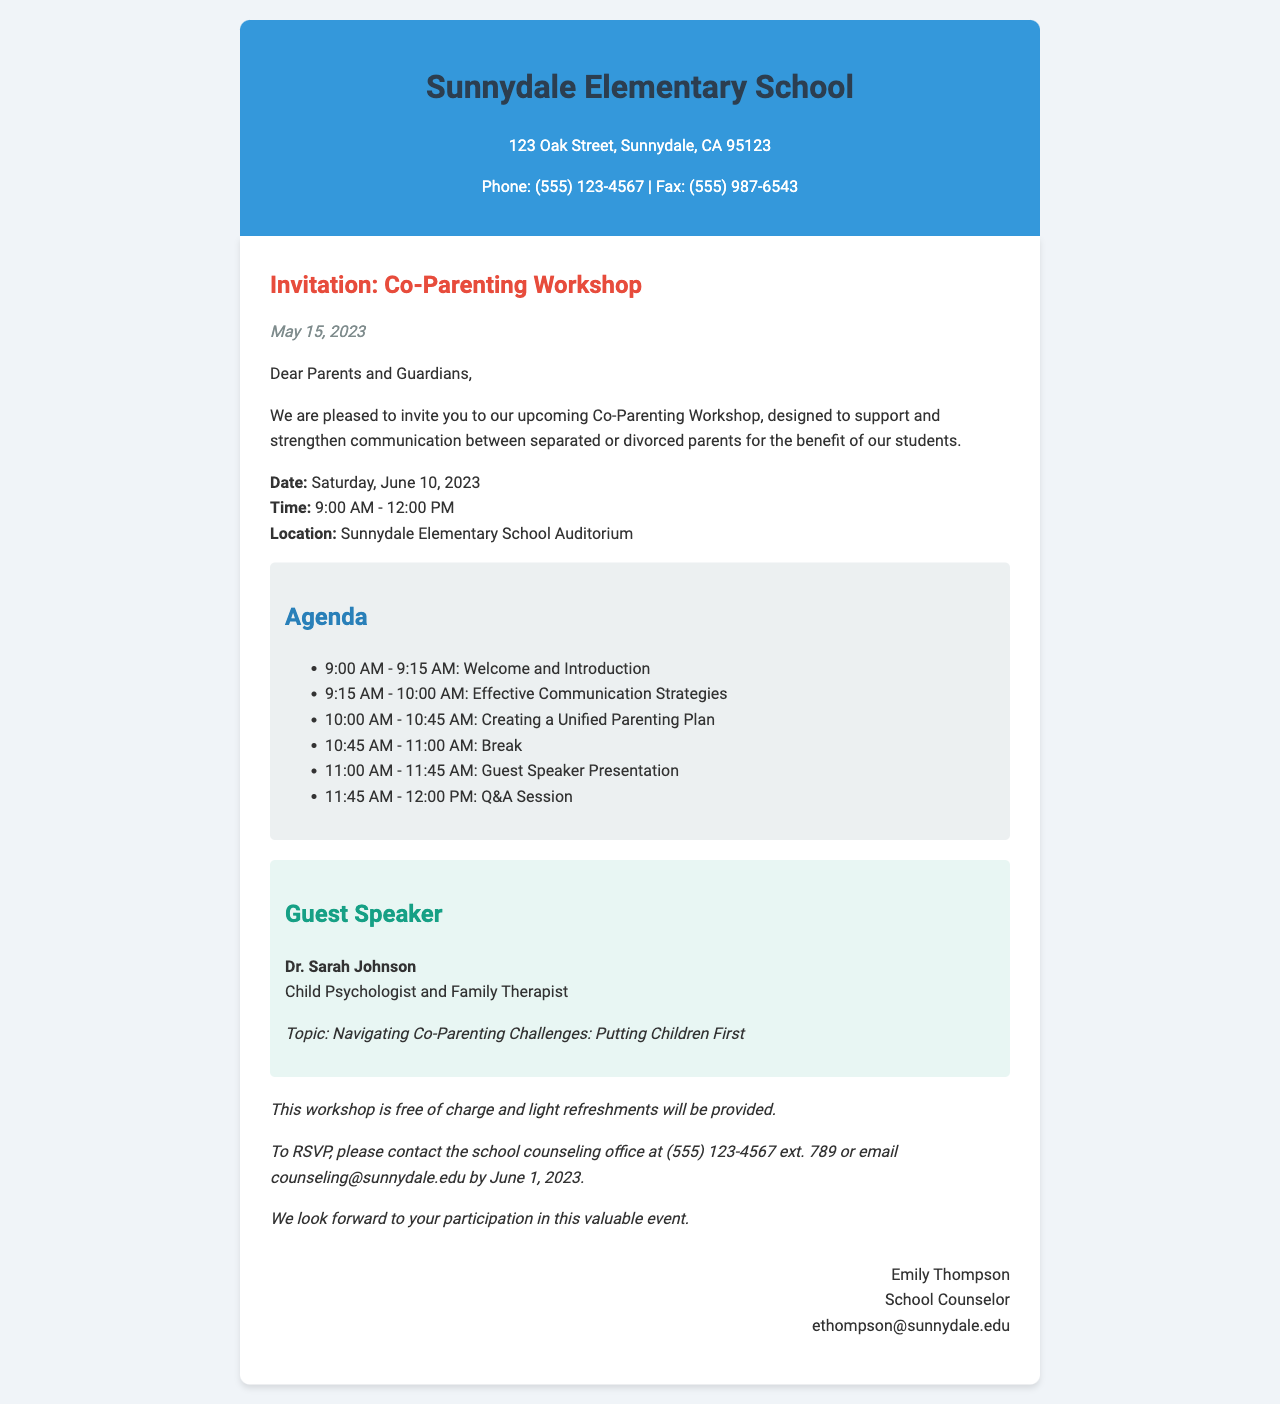what is the date of the workshop? The document specifies the date of the workshop as June 10, 2023.
Answer: June 10, 2023 who is the guest speaker? The guest speaker is named in the document as Dr. Sarah Johnson.
Answer: Dr. Sarah Johnson what time does the workshop start? The starting time of the workshop is indicated in the document as 9:00 AM.
Answer: 9:00 AM how long is the workshop scheduled to last? The document states that the workshop is scheduled from 9:00 AM to 12:00 PM, which is 3 hours.
Answer: 3 hours what is one of the topics covered in the agenda? The agenda lists several topics, including "Effective Communication Strategies."
Answer: Effective Communication Strategies what is the contact method for RSVPs? The document provides contact methods, specifically stating to call or email for RSVPs.
Answer: call or email what is the purpose of the workshop? The document mentions that the purpose is to support and strengthen communication between separated or divorced parents.
Answer: support and strengthen communication who sent the invitation? The signature section at the end of the document identifies Emily Thompson as the sender.
Answer: Emily Thompson 